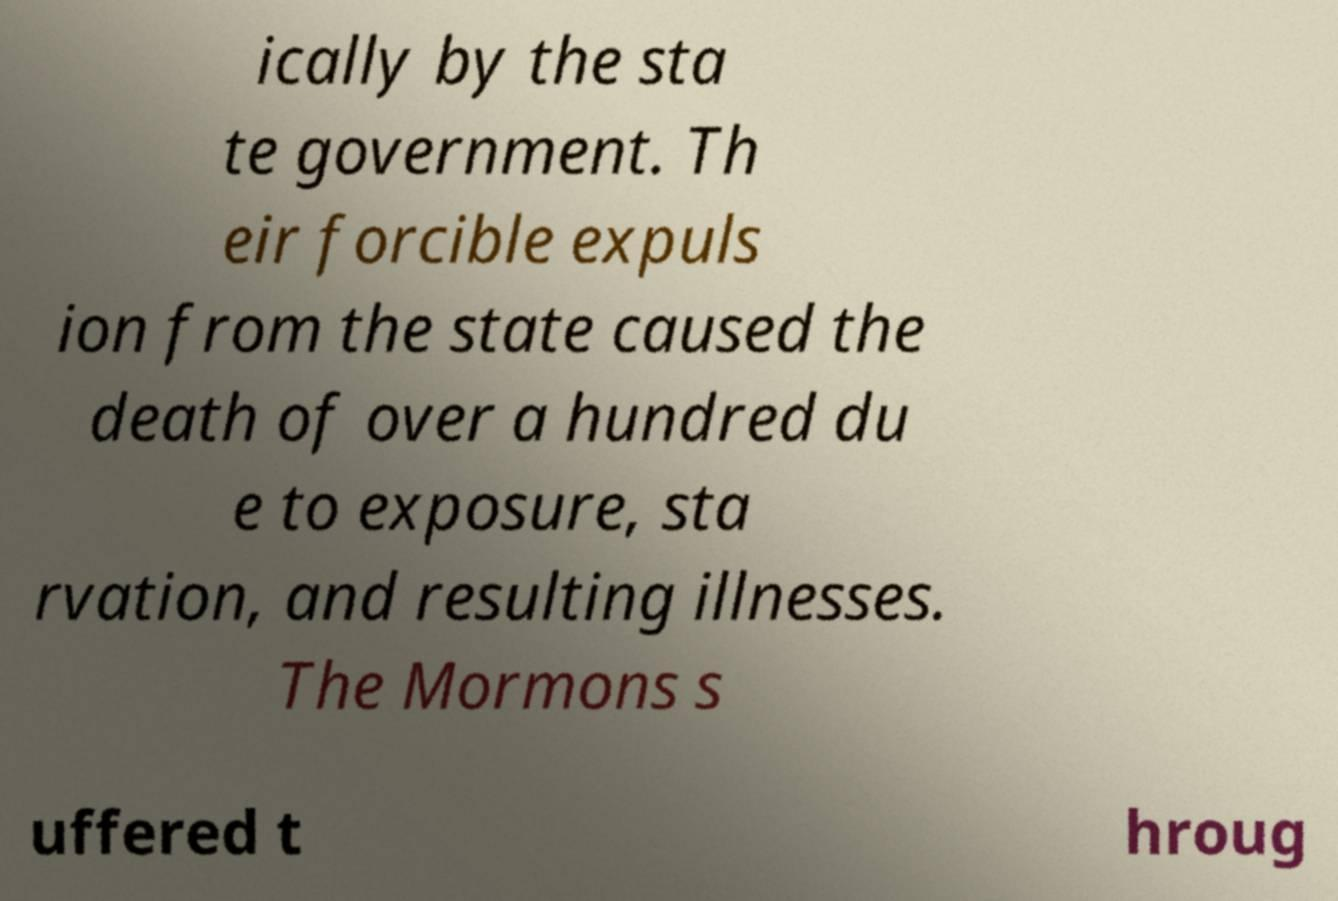For documentation purposes, I need the text within this image transcribed. Could you provide that? ically by the sta te government. Th eir forcible expuls ion from the state caused the death of over a hundred du e to exposure, sta rvation, and resulting illnesses. The Mormons s uffered t hroug 